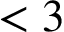<formula> <loc_0><loc_0><loc_500><loc_500>< 3</formula> 